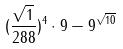Convert formula to latex. <formula><loc_0><loc_0><loc_500><loc_500>( \frac { \sqrt { 1 } } { 2 8 8 } ) ^ { 4 } \cdot 9 - 9 ^ { \sqrt { 1 0 } }</formula> 